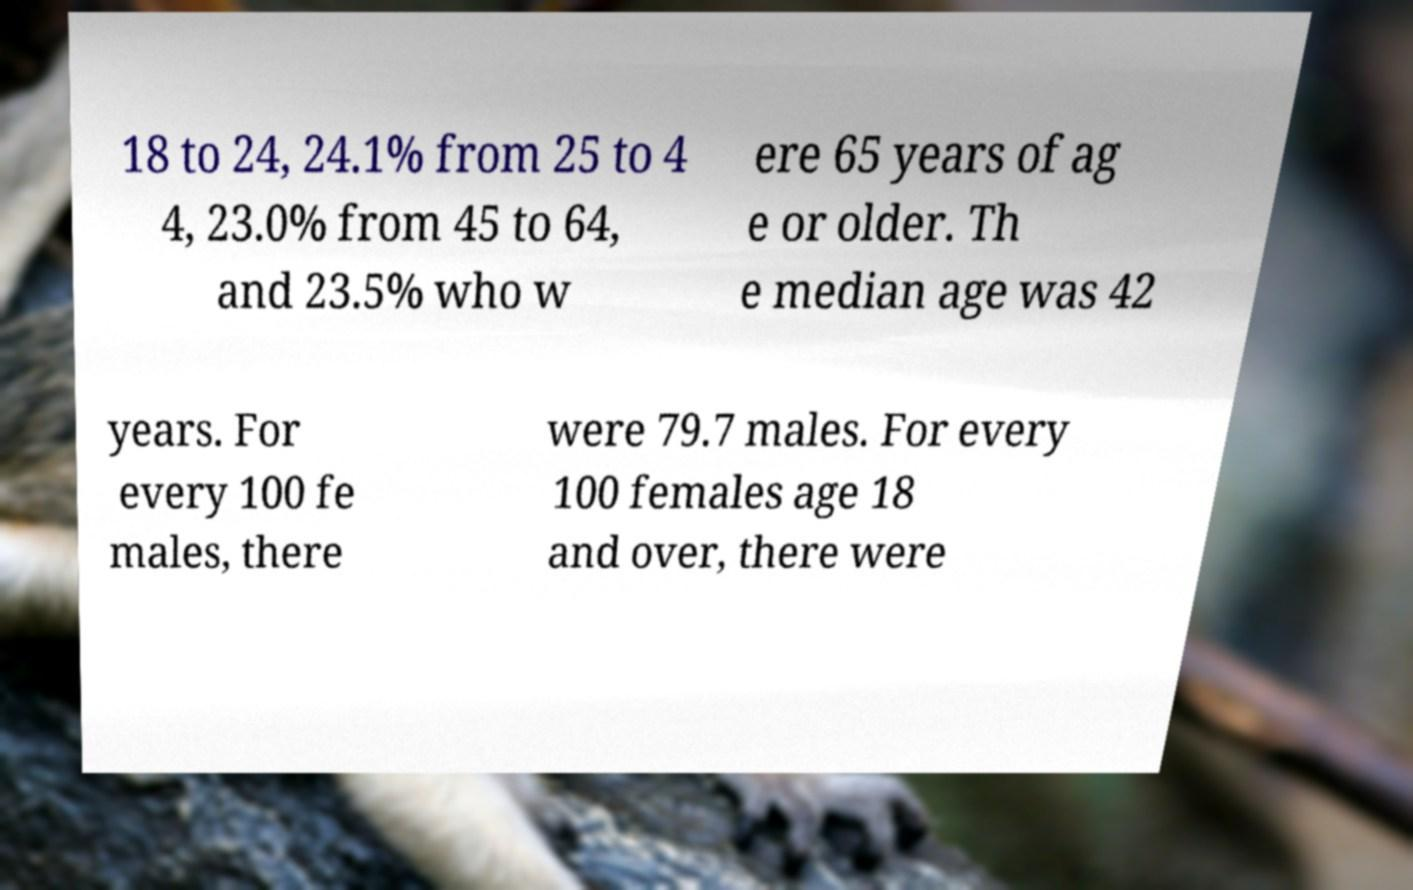Please identify and transcribe the text found in this image. 18 to 24, 24.1% from 25 to 4 4, 23.0% from 45 to 64, and 23.5% who w ere 65 years of ag e or older. Th e median age was 42 years. For every 100 fe males, there were 79.7 males. For every 100 females age 18 and over, there were 